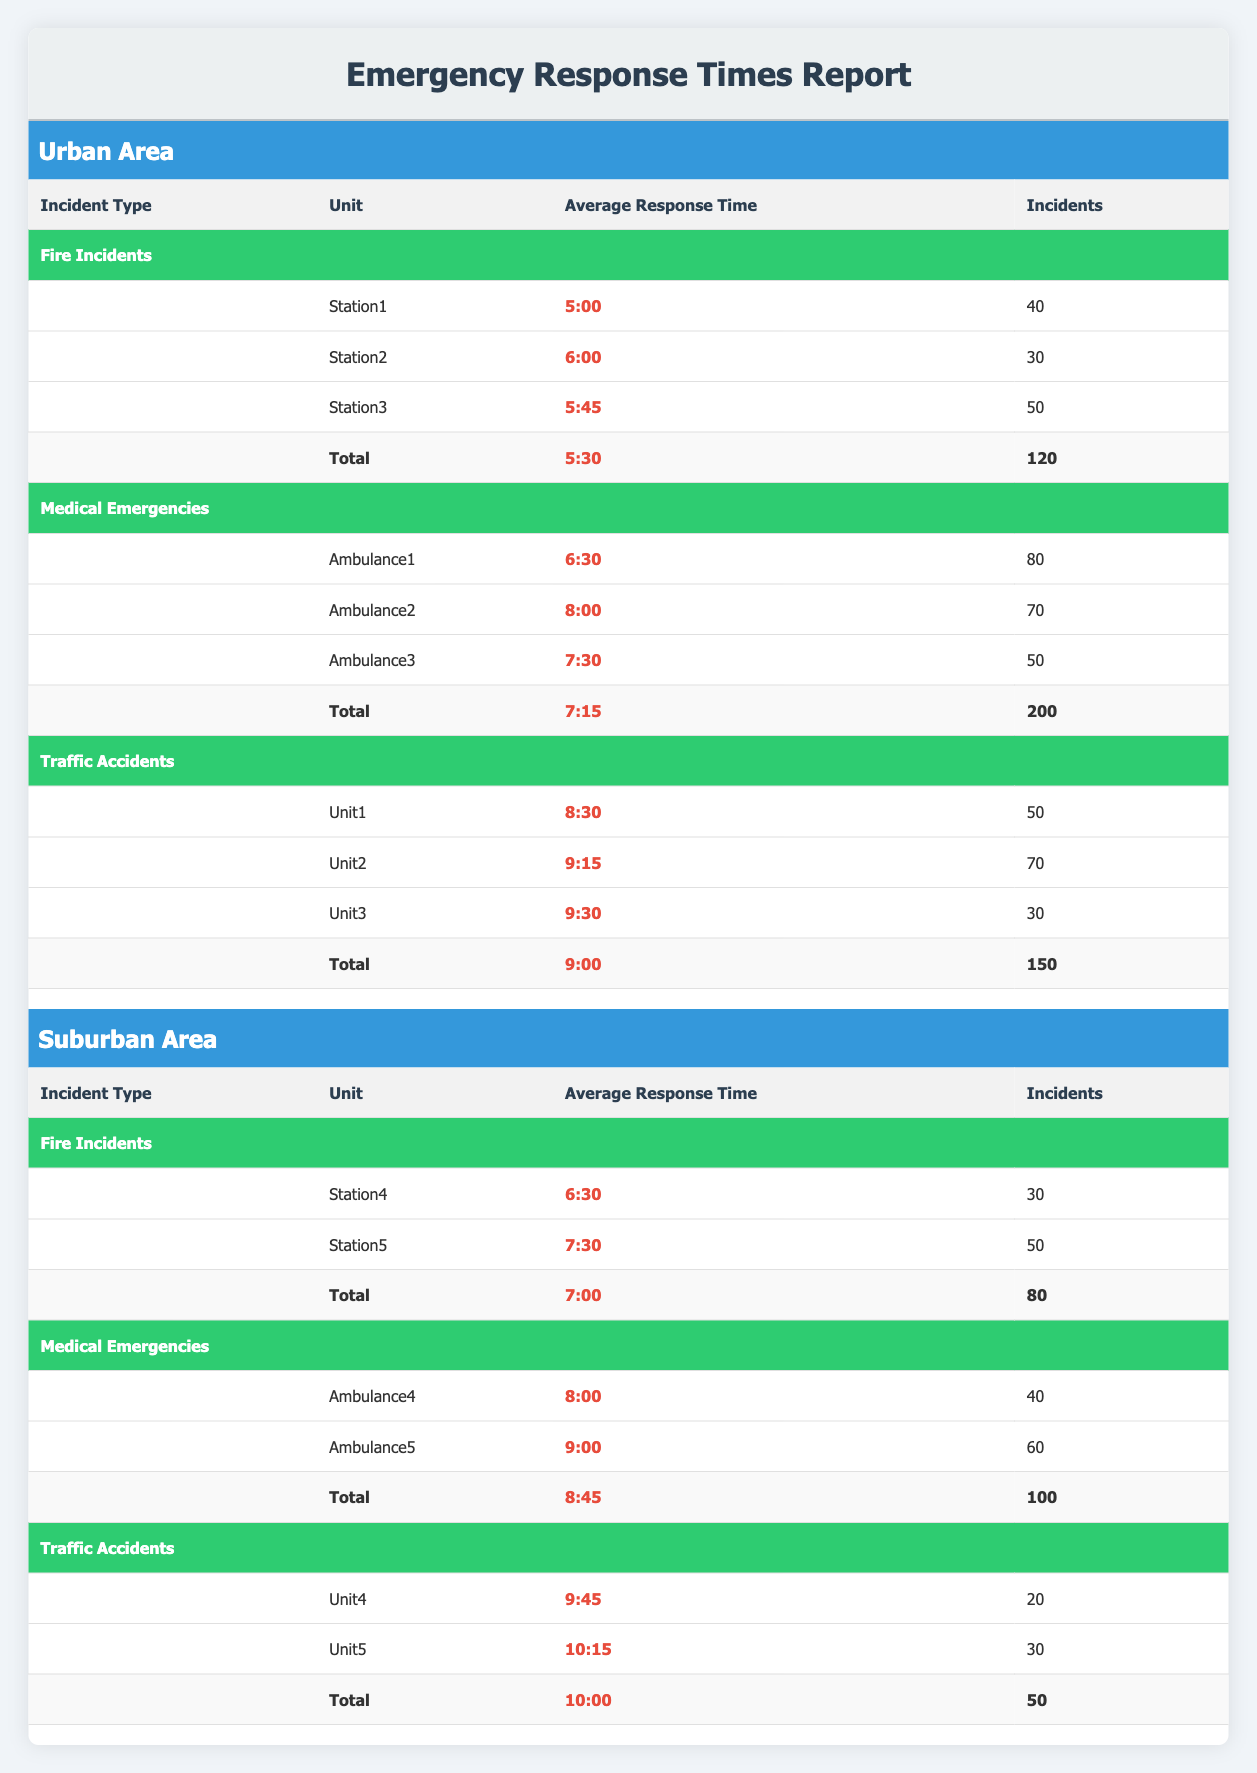What is the average response time for fire incidents in the urban area? The average response time for fire incidents in the urban area is listed in the total row for fire incidents, which is 5:30.
Answer: 5:30 How many medical emergencies were reported in the suburban area? The table shows the total incidents for medical emergencies in the suburban area as 100, found in the total row for medical emergencies.
Answer: 100 Which ambulance had the fastest average response time for medical emergencies in the urban area? Looking at the response times for ambulances in the urban area, Ambulance1 has an average response time of 6:30, which is the fastest compared to Ambulance2 and Ambulance3.
Answer: Ambulance1 Did fire incidents have a quicker average response time than traffic accidents in the suburban area? The average response time for fire incidents in the suburban area is 7:00, while for traffic accidents, it is 10:00. Since 7:00 is less than 10:00, fire incidents had a quicker average response time.
Answer: Yes What is the total average response time for all types of incidents in the urban area? To find the total average response time for all incidents in the urban area, we can average the average response times for fire incidents (5:30), medical emergencies (7:15), and traffic accidents (9:00). The sum is (5:30 in minutes is 330 + 7:15 in minutes is 435 + 9:00 in minutes is 540) = 1305 minutes. Dividing by 3 results in an average of 1305/3 = 435 minutes, which equals 7:15.
Answer: 7:15 How does the total number of traffic accidents in the suburban area compare to the urban area? The total incidents for traffic accidents in the suburban area is 50, while in the urban area it is 150. We can see that 150 is greater than 50, therefore, the urban area has more traffic accidents.
Answer: Urban area has more traffic accidents What is the average response time for traffic accidents across all ambulances in the suburban area? In the suburban area, the average response time for traffic accidents according to the total row is 10:00, which incorporates the response times of Unit4 (9:45) and Unit5 (10:15). Therefore, the average for traffic accidents is already provided as 10:00.
Answer: 10:00 Is the average response time for medical emergencies higher in the suburban area compared to the urban area? The average for medical emergencies in the suburban area is 8:45, whereas in the urban area it is 7:15. Since 8:45 is greater than 7:15, the average response time is indeed higher in the suburban area.
Answer: Yes Which incident type had the highest total number of reported incidents in the urban area? In the urban area, fire incidents reported 120, medical emergencies 200, and traffic accidents 150. Clearly, the highest number of incidents is for medical emergencies.
Answer: Medical emergencies 